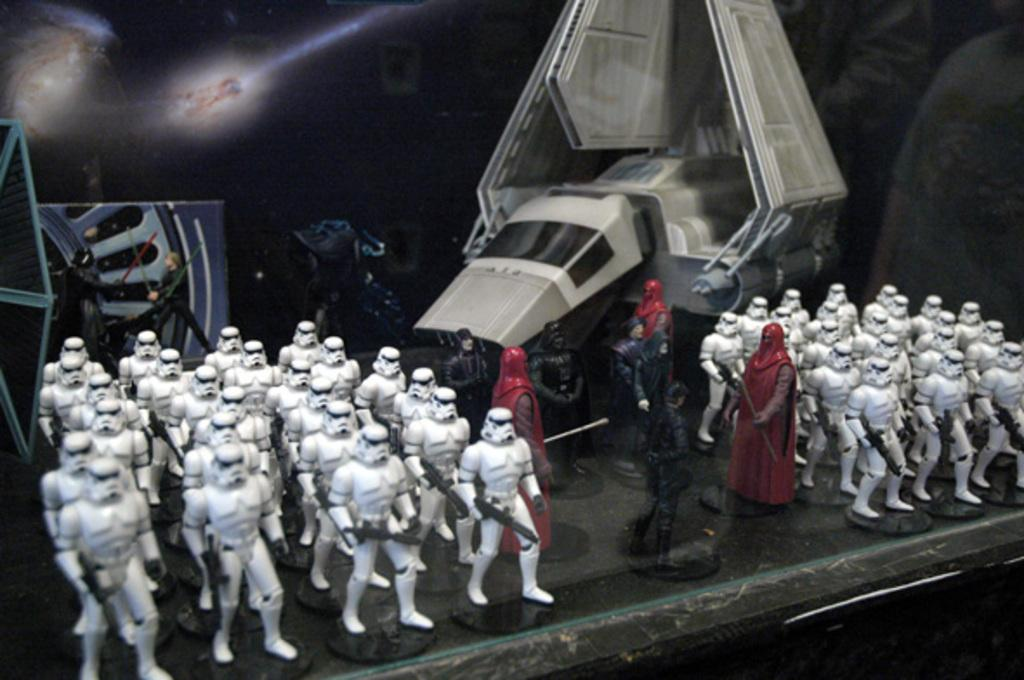What type of image is being described? The image is animated. What can be seen in the image besides the animated elements? There are machines and men in the image. Can you describe the setting or environment in the image? There is a background area in the image, which may contain a poster. Can you touch the sea in the image? There is no sea present in the image; it contains machines, men, and a background area. 